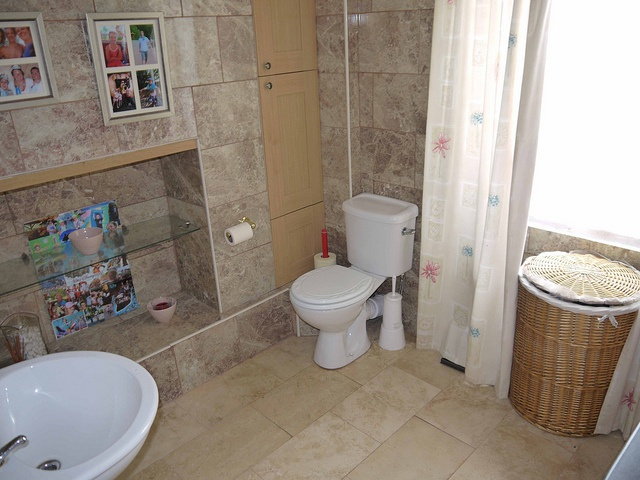Describe the objects in this image and their specific colors. I can see sink in gray, darkgray, and lightgray tones, toilet in gray and darkgray tones, vase in gray, maroon, and black tones, bowl in gray tones, and bowl in gray, maroon, and black tones in this image. 